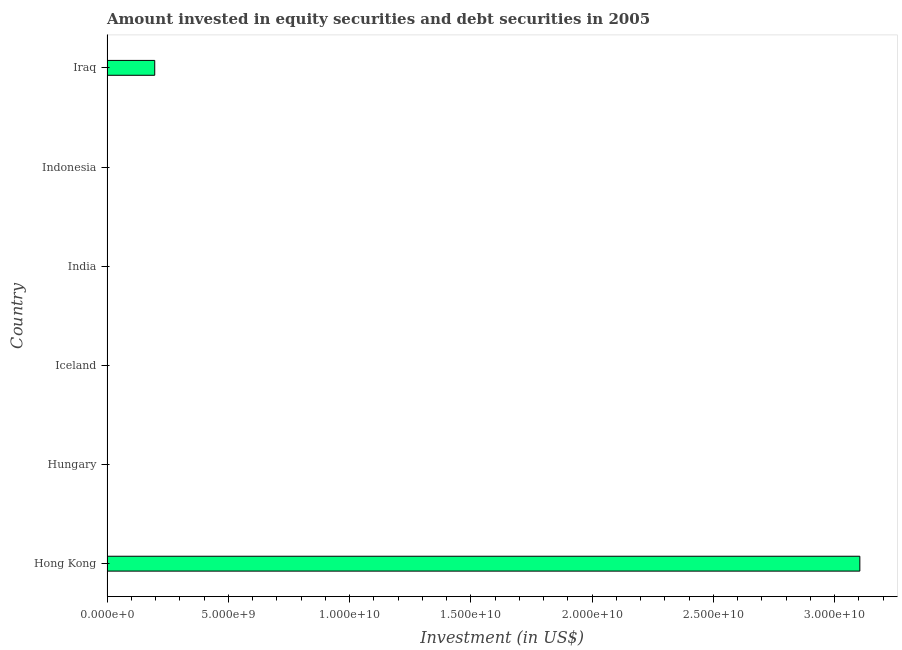Does the graph contain any zero values?
Provide a succinct answer. Yes. What is the title of the graph?
Your response must be concise. Amount invested in equity securities and debt securities in 2005. What is the label or title of the X-axis?
Offer a very short reply. Investment (in US$). What is the label or title of the Y-axis?
Ensure brevity in your answer.  Country. What is the portfolio investment in Iceland?
Make the answer very short. 0. Across all countries, what is the maximum portfolio investment?
Keep it short and to the point. 3.10e+1. In which country was the portfolio investment maximum?
Provide a short and direct response. Hong Kong. What is the sum of the portfolio investment?
Provide a short and direct response. 3.30e+1. What is the average portfolio investment per country?
Your answer should be compact. 5.50e+09. In how many countries, is the portfolio investment greater than 27000000000 US$?
Your answer should be compact. 1. What is the difference between the highest and the lowest portfolio investment?
Offer a very short reply. 3.10e+1. Are all the bars in the graph horizontal?
Give a very brief answer. Yes. How many countries are there in the graph?
Provide a short and direct response. 6. What is the difference between two consecutive major ticks on the X-axis?
Make the answer very short. 5.00e+09. What is the Investment (in US$) in Hong Kong?
Provide a short and direct response. 3.10e+1. What is the Investment (in US$) of India?
Your answer should be very brief. 0. What is the Investment (in US$) in Iraq?
Ensure brevity in your answer.  1.97e+09. What is the difference between the Investment (in US$) in Hong Kong and Iraq?
Offer a very short reply. 2.91e+1. What is the ratio of the Investment (in US$) in Hong Kong to that in Iraq?
Your answer should be very brief. 15.78. 